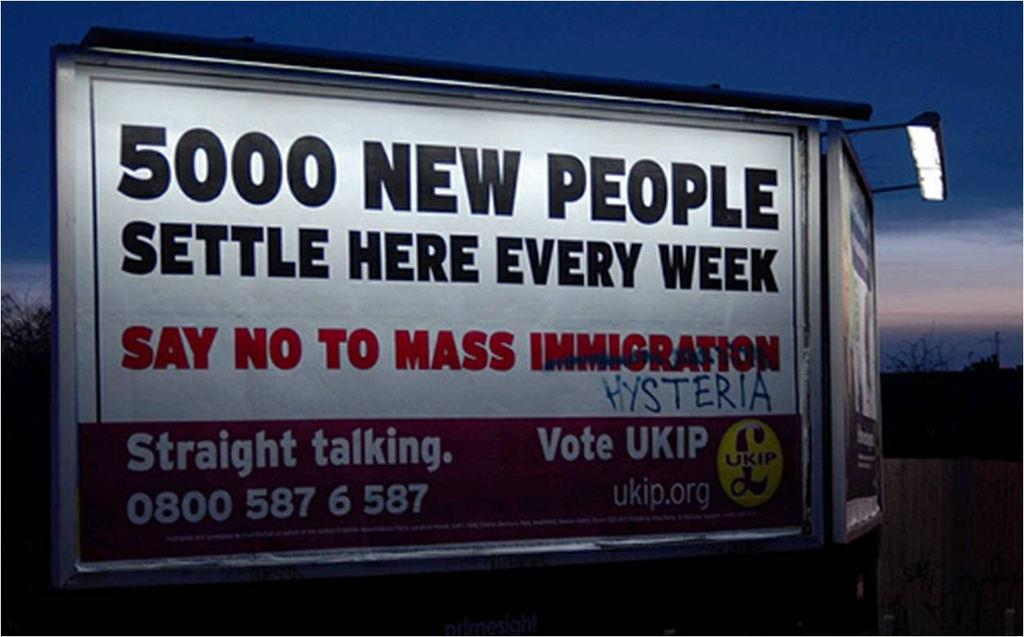<image>
Describe the image concisely. A billboard discussing how many people settle every week in the area provided by UKIP 